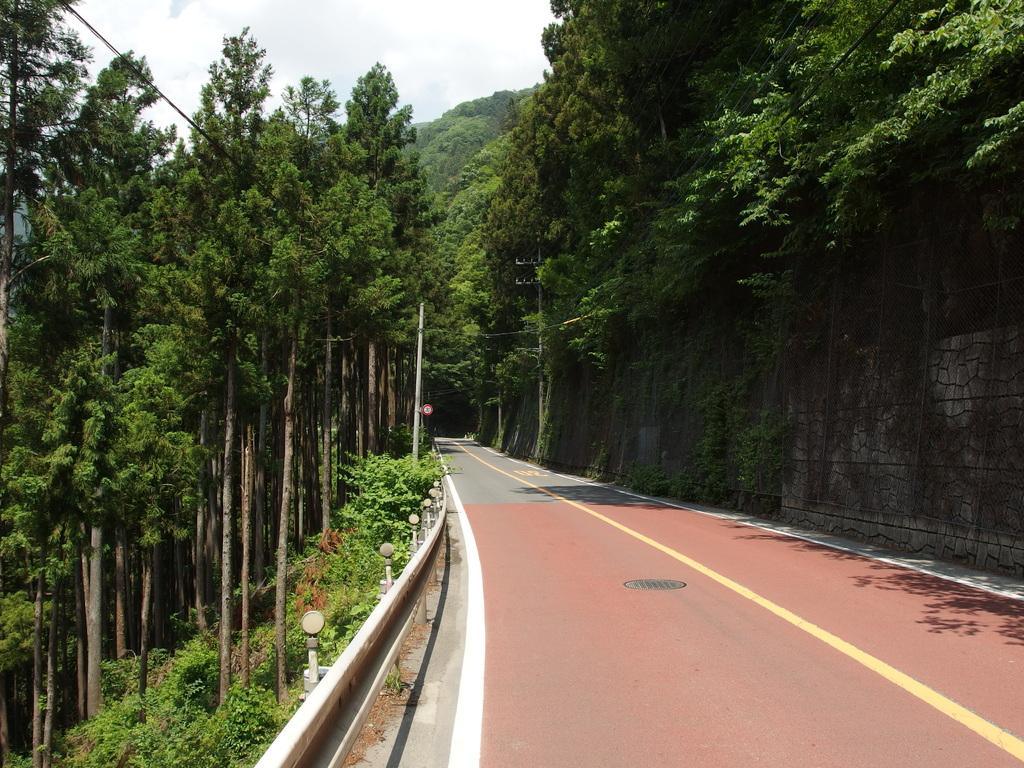What type of vegetation is visible in the image? There are trees in the image. What structures can be seen in the image? There are poles and sign boards visible in the image. What type of pathway is present in the image? There is a road in the image. What natural features are visible in the image? There are hills in the image. What is visible in the sky in the image? The sky is visible in the image, and there are clouds present. Can you see a pig cooking something on the road in the image? There is no pig or cooking activity present in the image. What type of body is visible on the sign boards in the image? The sign boards in the image do not depict any bodies; they contain text and symbols. 